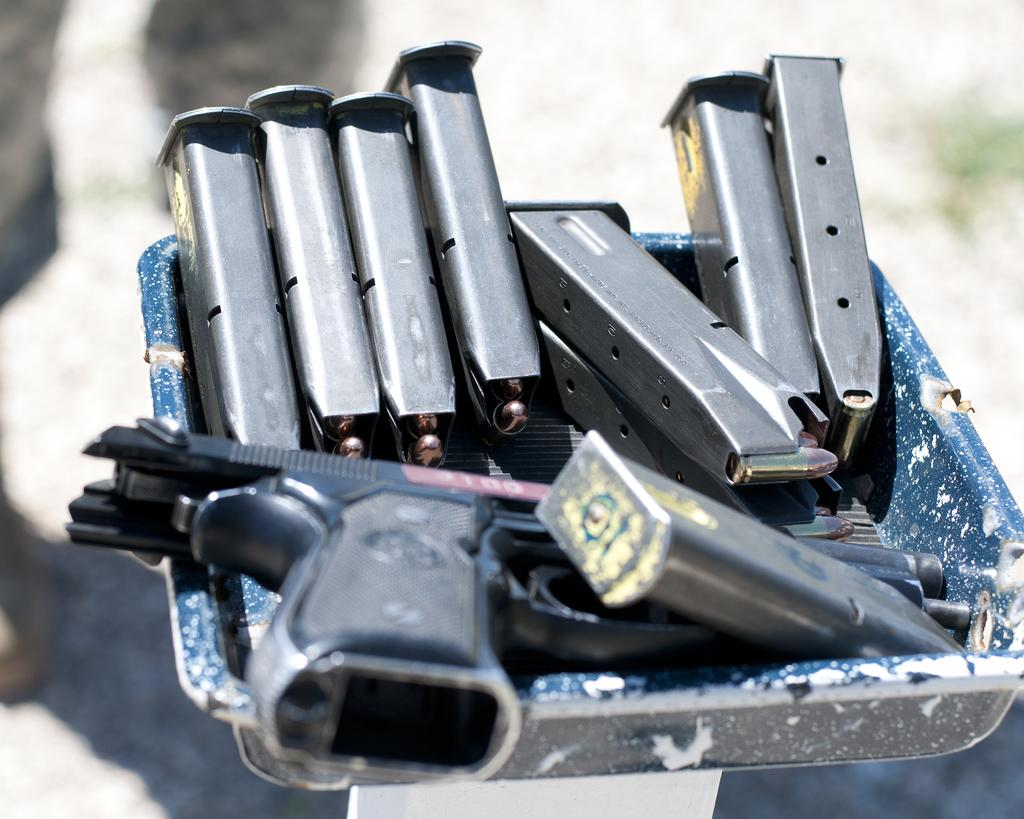What object is present in the image that can hold items? There is a tray in the image that can hold items. What types of items are in the tray? There are magazines, bullets, and a gun in the tray. Can you describe the contents of the tray in more detail? The tray contains magazines, a collection of bullets, and a gun. What can be said about the background of the image? The background of the image is blurred. What type of square can be seen in the image? There is no square present in the image. Can you tell me how the whistle is being used in the image? There is no whistle present in the image, so it cannot be used or observed. 